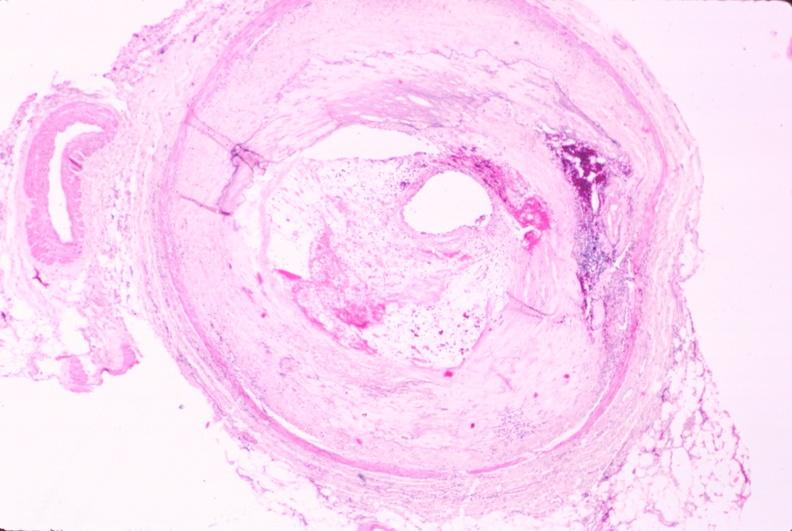s cardiovascular present?
Answer the question using a single word or phrase. Yes 